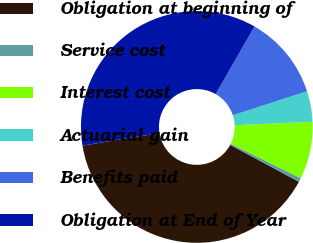<chart> <loc_0><loc_0><loc_500><loc_500><pie_chart><fcel>Obligation at beginning of<fcel>Service cost<fcel>Interest cost<fcel>Actuarial gain<fcel>Benefits paid<fcel>Obligation at End of Year<nl><fcel>39.59%<fcel>0.55%<fcel>8.0%<fcel>4.27%<fcel>11.72%<fcel>35.87%<nl></chart> 